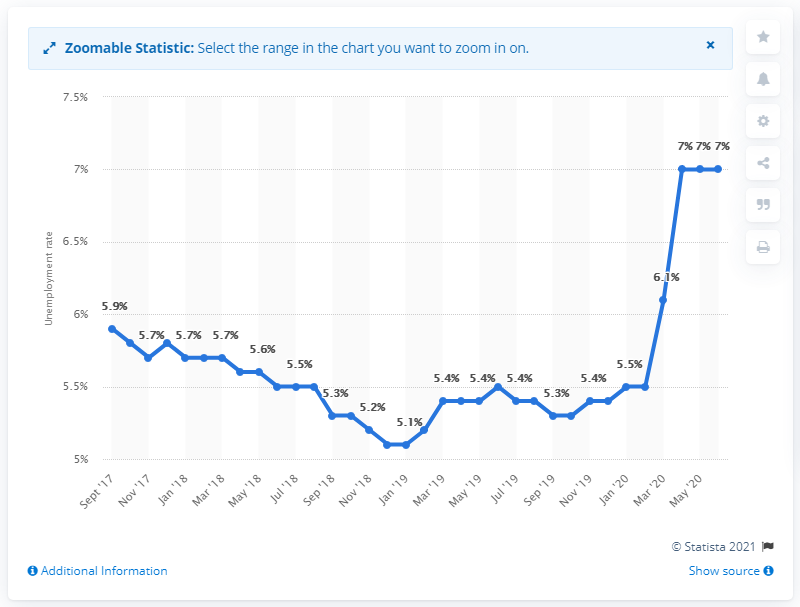How might this data influence governmental policy in Luxembourg? The government might use this data as an impetus to create or augment employment support programs, stimulate the economy through fiscal measures, or work to attract foreign investment to create jobs and decrease unemployment rates. 